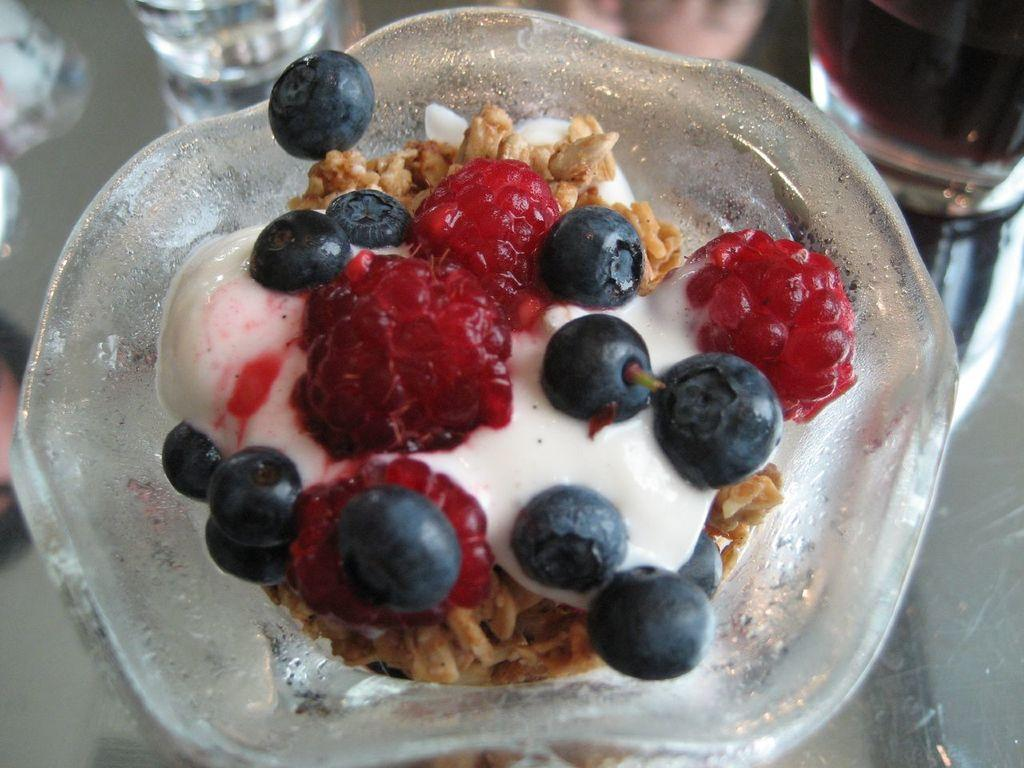What type of food item is in the bowl in the image? The specific type of food item in the bowl is not mentioned, but there is a food item in a bowl in the image. What else can be seen in the image besides the bowl of food? There are glasses with drinks in the image. Where are the glasses with drinks located? The glasses with drinks are placed on a table. What type of leather material is visible on the building in the image? There is no building or leather material present in the image. What type of house is shown in the image? There is no house shown in the image; it only features a bowl of food and glasses with drinks. 